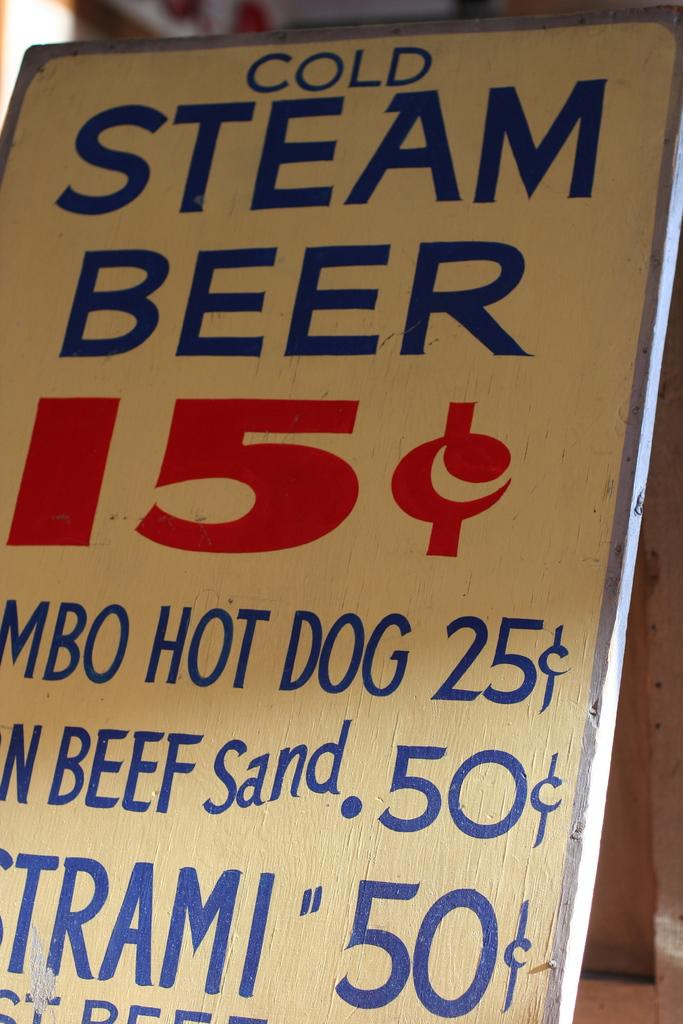<image>
Create a compact narrative representing the image presented. A painted board says Ice Cold Steam Beer in blue letters. 